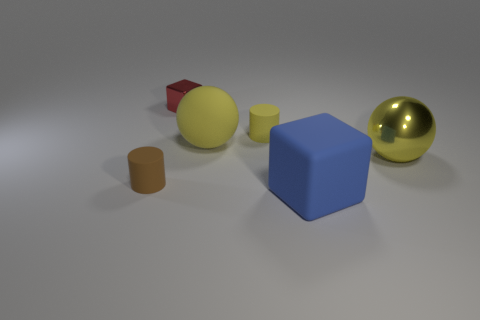Subtract all brown blocks. Subtract all cyan cylinders. How many blocks are left? 2 Add 1 big matte objects. How many objects exist? 7 Subtract all balls. How many objects are left? 4 Add 2 small cylinders. How many small cylinders are left? 4 Add 6 yellow rubber cylinders. How many yellow rubber cylinders exist? 7 Subtract 0 brown balls. How many objects are left? 6 Subtract all brown objects. Subtract all cylinders. How many objects are left? 3 